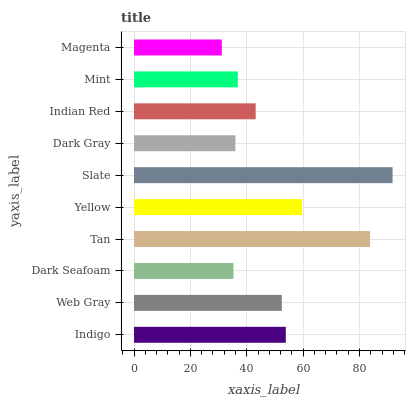Is Magenta the minimum?
Answer yes or no. Yes. Is Slate the maximum?
Answer yes or no. Yes. Is Web Gray the minimum?
Answer yes or no. No. Is Web Gray the maximum?
Answer yes or no. No. Is Indigo greater than Web Gray?
Answer yes or no. Yes. Is Web Gray less than Indigo?
Answer yes or no. Yes. Is Web Gray greater than Indigo?
Answer yes or no. No. Is Indigo less than Web Gray?
Answer yes or no. No. Is Web Gray the high median?
Answer yes or no. Yes. Is Indian Red the low median?
Answer yes or no. Yes. Is Yellow the high median?
Answer yes or no. No. Is Magenta the low median?
Answer yes or no. No. 